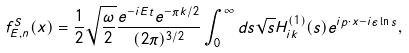<formula> <loc_0><loc_0><loc_500><loc_500>f ^ { S } _ { E , { n } } ( x ) = \frac { 1 } { 2 } \sqrt { \frac { \omega } { 2 } } \frac { e ^ { - i E t } e ^ { - \pi k / 2 } } { ( 2 \pi ) ^ { 3 / 2 } } \int _ { 0 } ^ { \infty } d s \sqrt { s } H ^ { ( 1 ) } _ { i k } ( s ) e ^ { i { p } \cdot { x } - i \epsilon \ln s } ,</formula> 